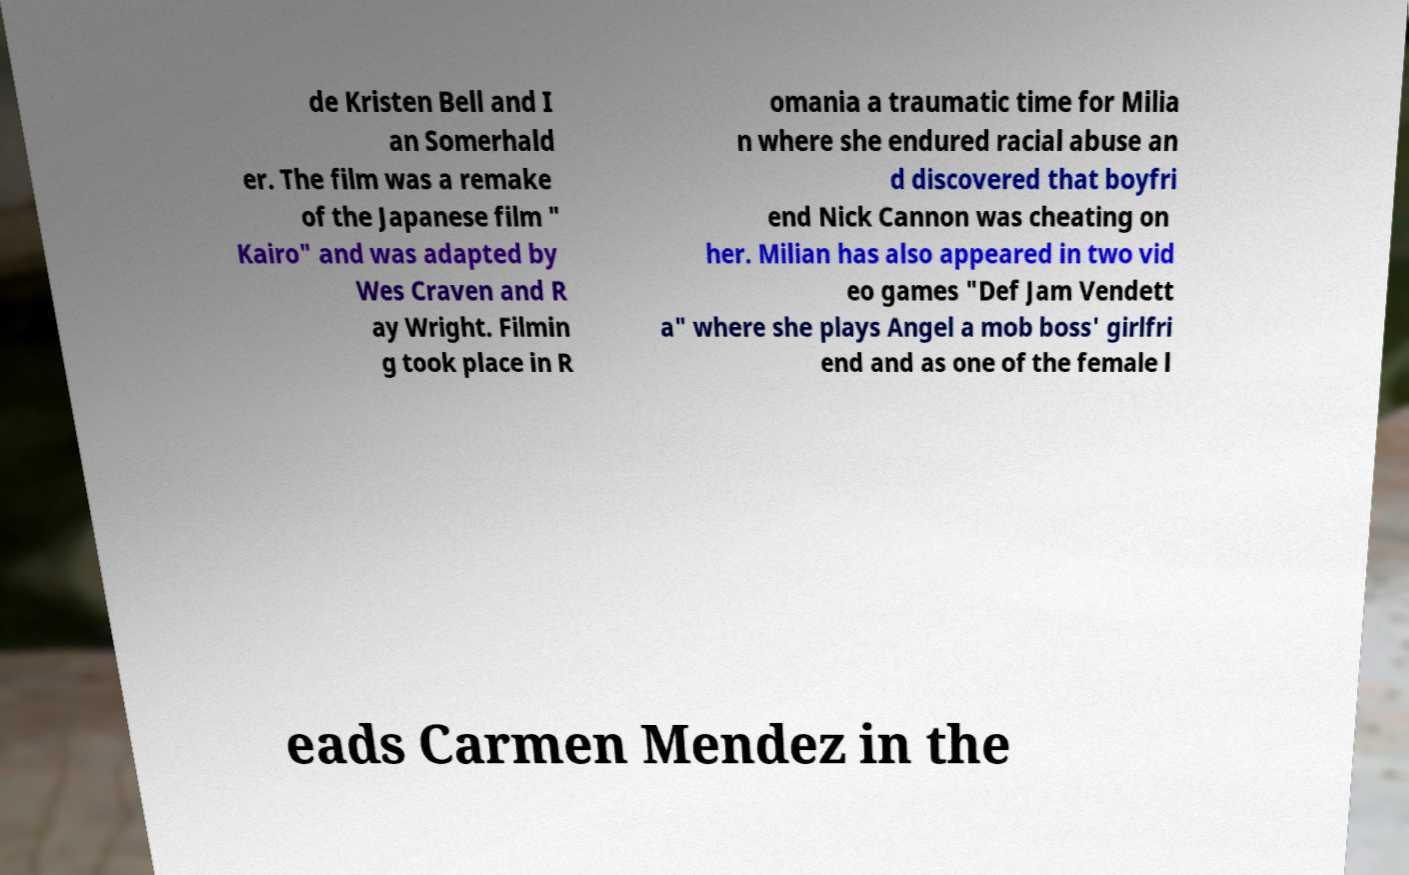Could you extract and type out the text from this image? de Kristen Bell and I an Somerhald er. The film was a remake of the Japanese film " Kairo" and was adapted by Wes Craven and R ay Wright. Filmin g took place in R omania a traumatic time for Milia n where she endured racial abuse an d discovered that boyfri end Nick Cannon was cheating on her. Milian has also appeared in two vid eo games "Def Jam Vendett a" where she plays Angel a mob boss' girlfri end and as one of the female l eads Carmen Mendez in the 